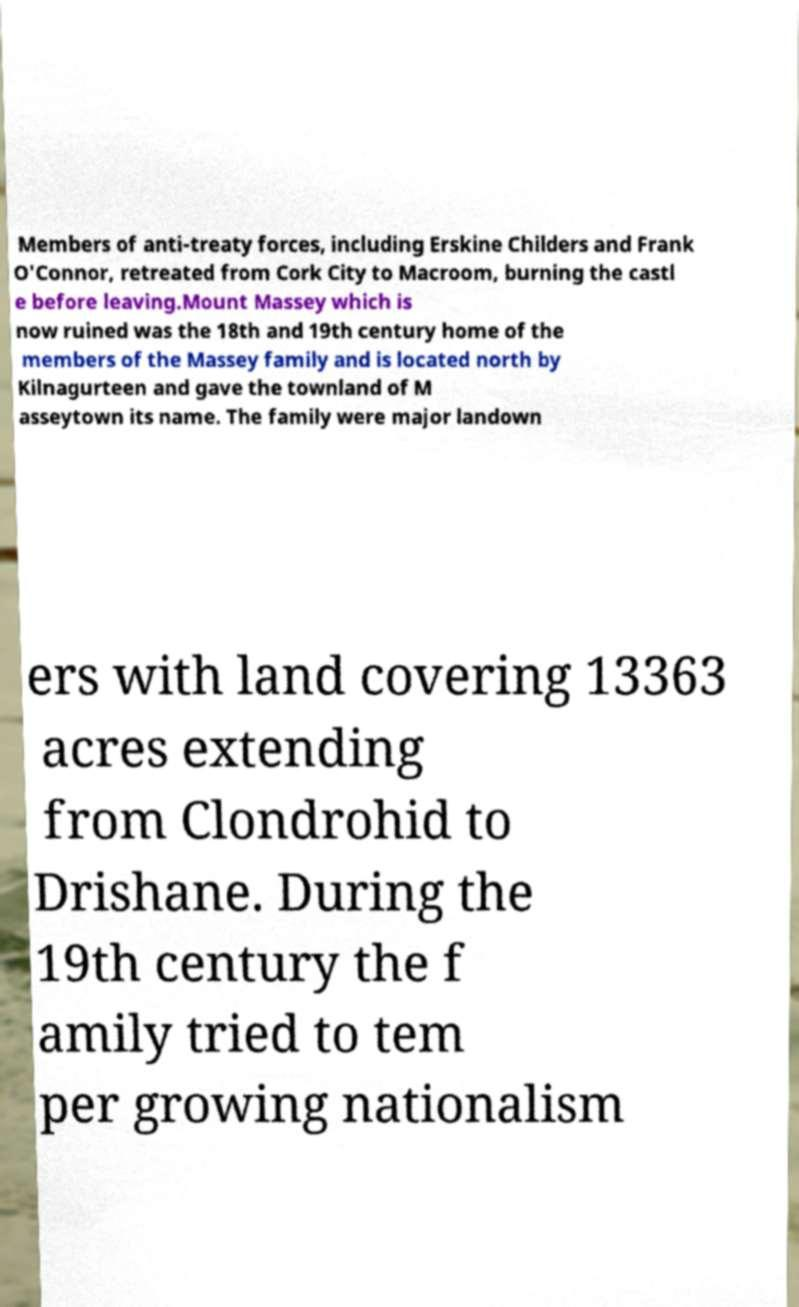Can you read and provide the text displayed in the image?This photo seems to have some interesting text. Can you extract and type it out for me? Members of anti-treaty forces, including Erskine Childers and Frank O'Connor, retreated from Cork City to Macroom, burning the castl e before leaving.Mount Massey which is now ruined was the 18th and 19th century home of the members of the Massey family and is located north by Kilnagurteen and gave the townland of M asseytown its name. The family were major landown ers with land covering 13363 acres extending from Clondrohid to Drishane. During the 19th century the f amily tried to tem per growing nationalism 